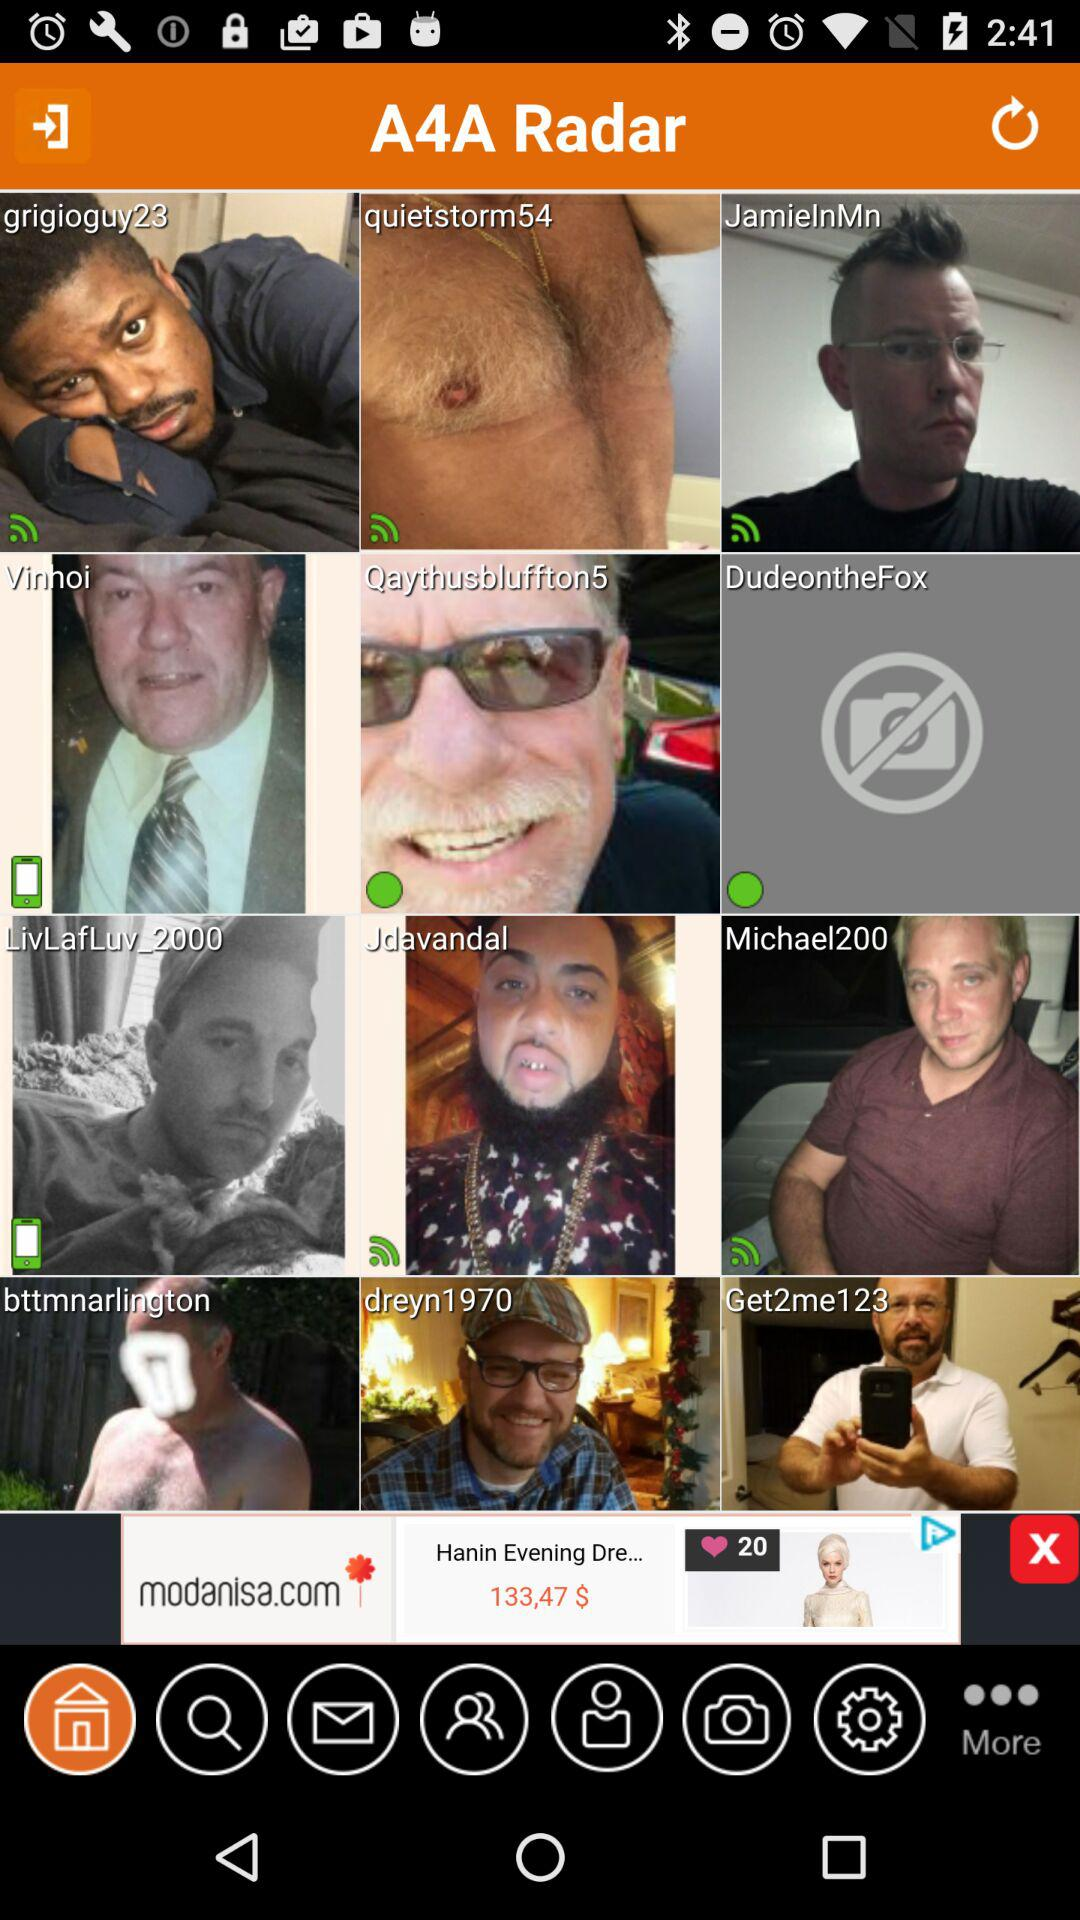How old is "Jdavandal"?
When the provided information is insufficient, respond with <no answer>. <no answer> 